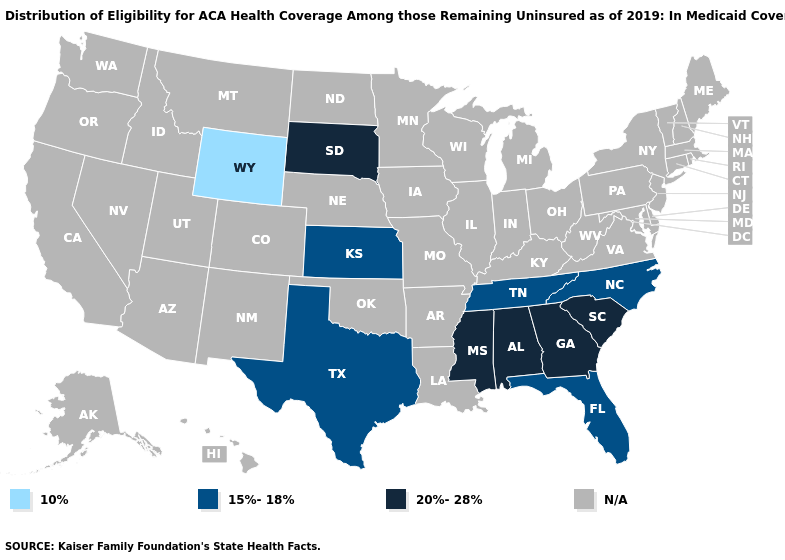What is the value of Colorado?
Be succinct. N/A. What is the value of Wyoming?
Write a very short answer. 10%. Does South Dakota have the lowest value in the MidWest?
Be succinct. No. Name the states that have a value in the range 10%?
Keep it brief. Wyoming. What is the value of Nebraska?
Answer briefly. N/A. What is the value of Washington?
Quick response, please. N/A. What is the value of Hawaii?
Quick response, please. N/A. What is the value of Alabama?
Be succinct. 20%-28%. Name the states that have a value in the range 15%-18%?
Give a very brief answer. Florida, Kansas, North Carolina, Tennessee, Texas. Name the states that have a value in the range N/A?
Quick response, please. Alaska, Arizona, Arkansas, California, Colorado, Connecticut, Delaware, Hawaii, Idaho, Illinois, Indiana, Iowa, Kentucky, Louisiana, Maine, Maryland, Massachusetts, Michigan, Minnesota, Missouri, Montana, Nebraska, Nevada, New Hampshire, New Jersey, New Mexico, New York, North Dakota, Ohio, Oklahoma, Oregon, Pennsylvania, Rhode Island, Utah, Vermont, Virginia, Washington, West Virginia, Wisconsin. 